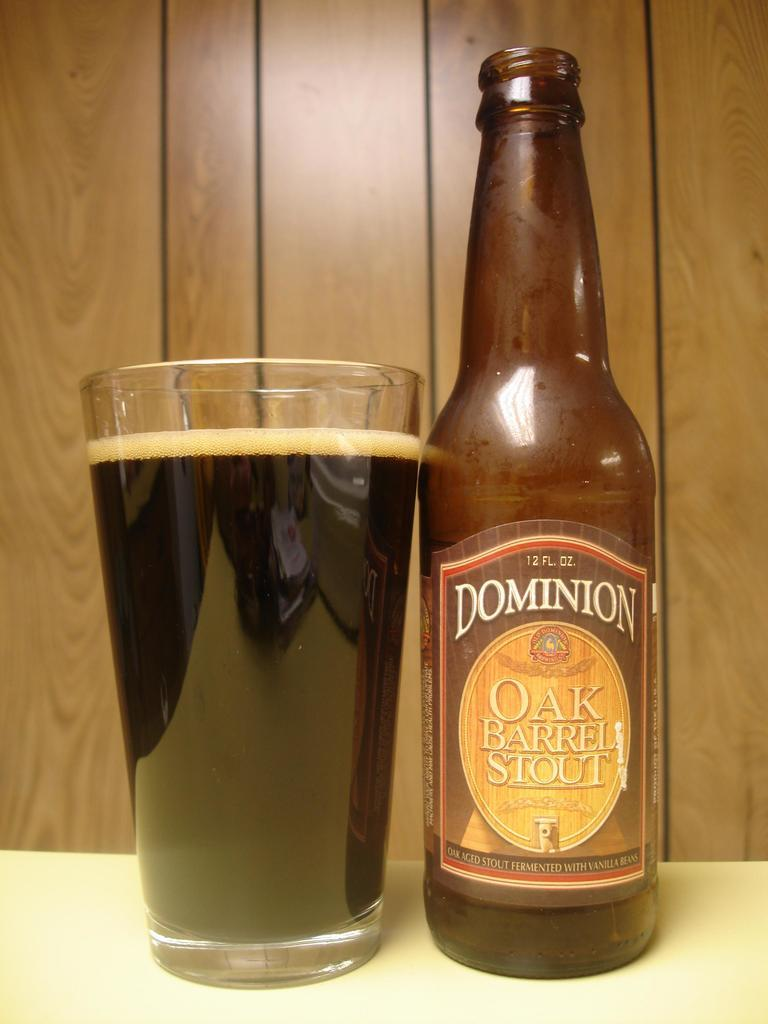<image>
Provide a brief description of the given image. A glass of Oak Barrel Stout sits next to an empty bottle. 